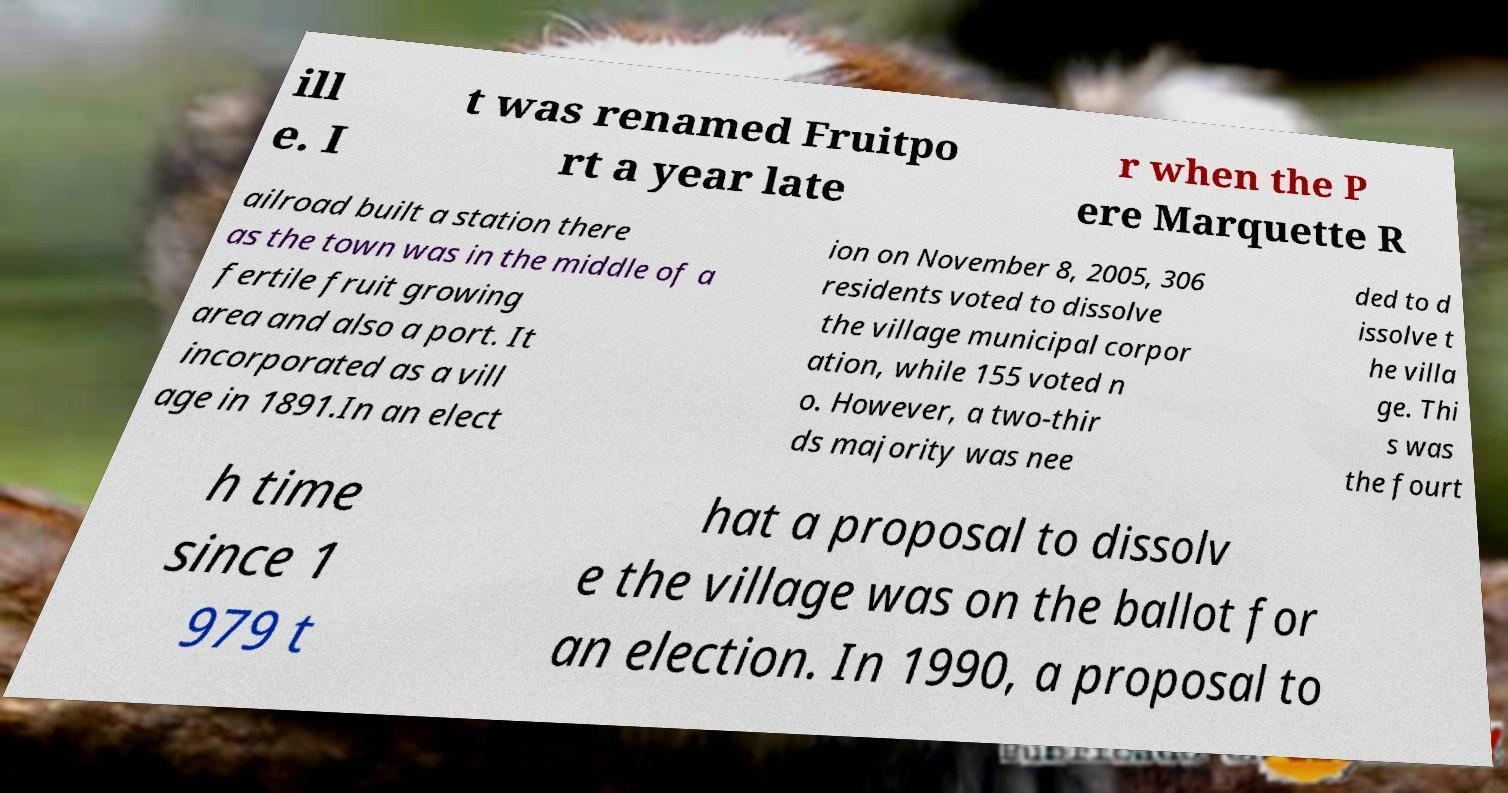Can you accurately transcribe the text from the provided image for me? ill e. I t was renamed Fruitpo rt a year late r when the P ere Marquette R ailroad built a station there as the town was in the middle of a fertile fruit growing area and also a port. It incorporated as a vill age in 1891.In an elect ion on November 8, 2005, 306 residents voted to dissolve the village municipal corpor ation, while 155 voted n o. However, a two-thir ds majority was nee ded to d issolve t he villa ge. Thi s was the fourt h time since 1 979 t hat a proposal to dissolv e the village was on the ballot for an election. In 1990, a proposal to 